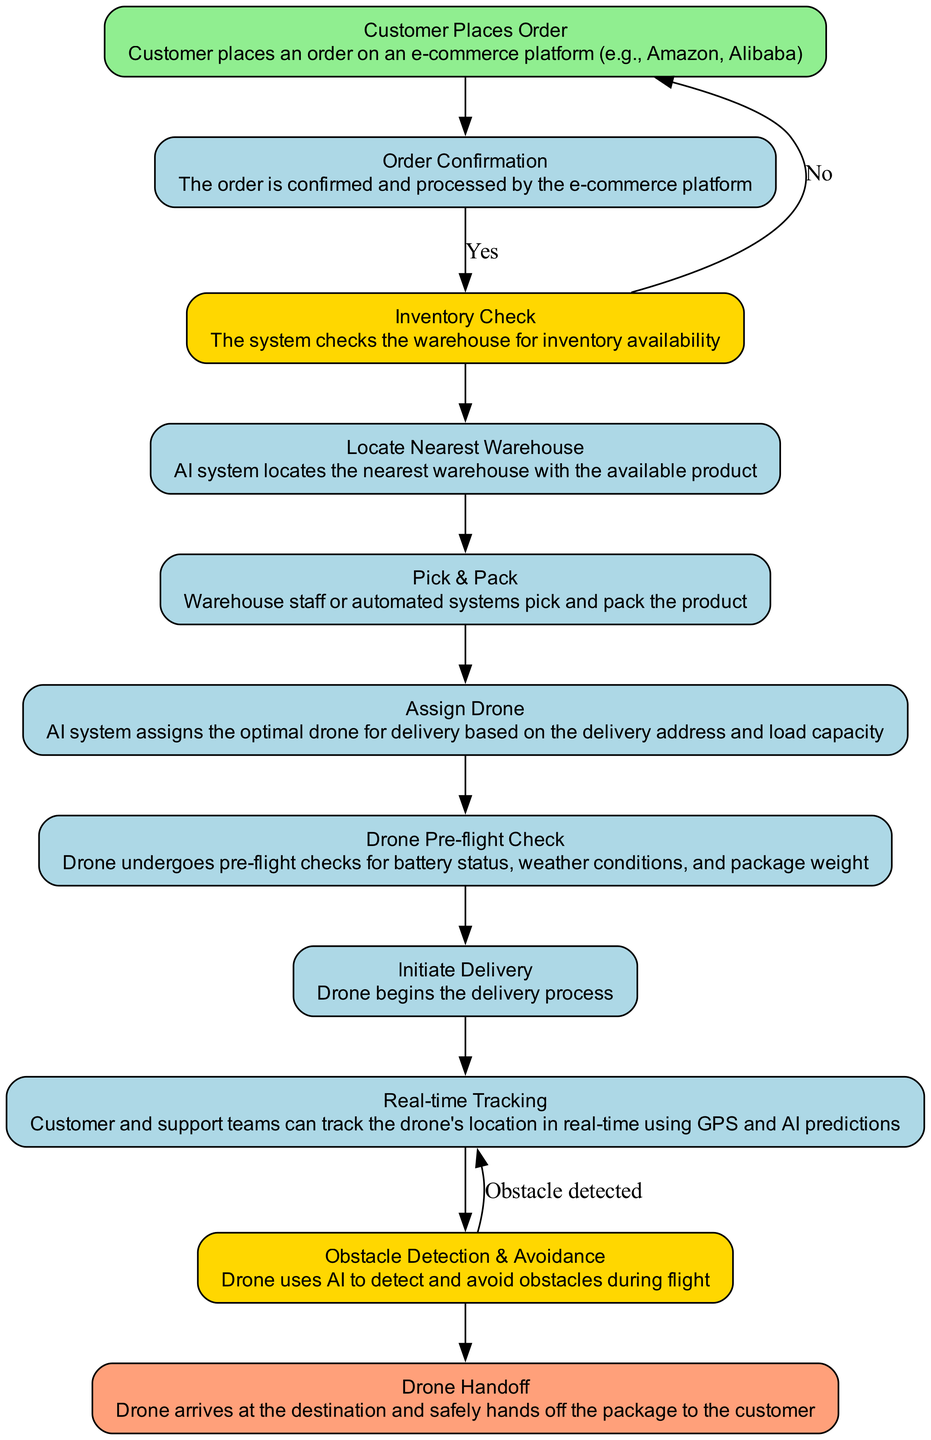What is the first step in the diagram? The first step is indicated by the "Start" node, labeled "Customer Places Order," which is where the process begins.
Answer: Customer Places Order How many total nodes are present in the flow? The flow chart contains a total of 10 nodes representing various steps and decisions in the e-commerce logistics process.
Answer: 10 What is the process that follows "Order Confirmation"? After "Order Confirmation," the next process is "Inventory Check," which checks if the ordered product is available in stock.
Answer: Inventory Check What type of node is "Obstacle Detection & Avoidance"? "Obstacle Detection & Avoidance" is categorized as a "Decision" node, indicating that the process requires evaluation based on certain conditions during the drone's flight.
Answer: Decision What action precedes the "Drone Handoff"? The action that precedes "Drone Handoff" is "Obstacle Detection & Avoidance," where the drone needs to detect and avoid any obstacles before successfully handing over the package.
Answer: Obstacle Detection & Avoidance If the inventory is not available, what happens next? If the inventory is not available, the next action returns to "Locate Nearest Warehouse," indicating a repetition of the process to find an appropriate warehouse that has the product.
Answer: Locate Nearest Warehouse What is the purpose of the "Drone Pre-flight Check"? The purpose of the "Drone Pre-flight Check" is to ensure the drone is ready for delivery by checking its battery status, weather conditions, and package weight before takeoff.
Answer: Ensure readiness How does real-time tracking benefit customers? Real-time tracking allows customers and support teams to monitor the drone's location during delivery, enhancing transparency and support during the process.
Answer: Monitor location What happens after "Initiate Delivery"? After "Initiate Delivery," the process moves to "Real-time Tracking," where tracking mechanisms are established to follow the drone's journey to the customer.
Answer: Real-time Tracking What is the final step in this flowchart? The final step in the flowchart is "Drone Handoff," which signifies the completion of the delivery process when the drone successfully delivers the package to the customer.
Answer: Drone Handoff 